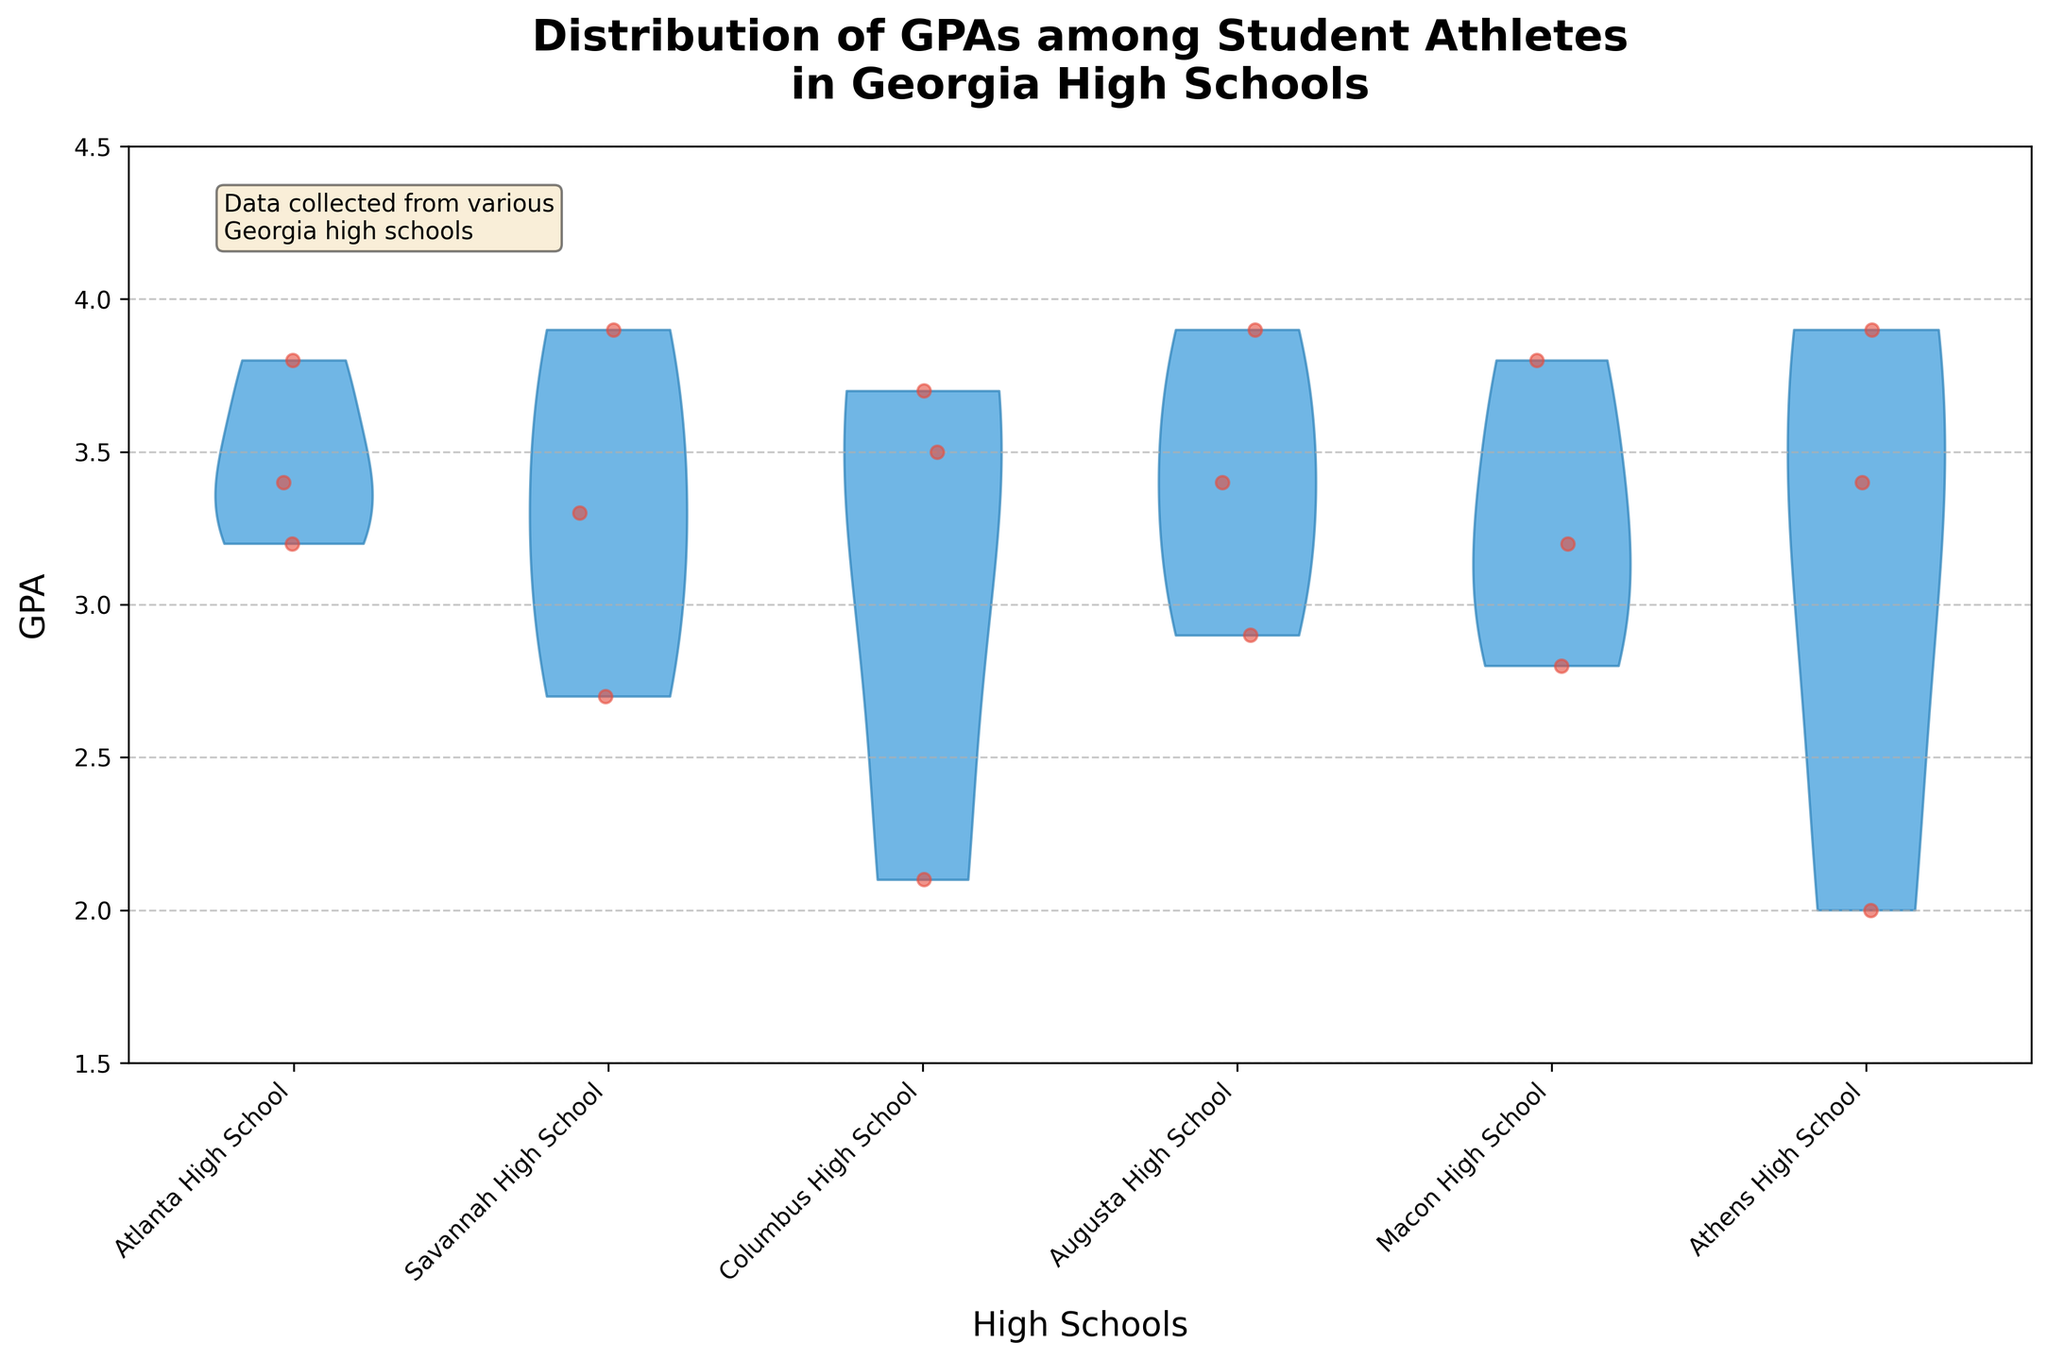Which high school shows the widest distribution of GPAs among student athletes? To determine the widest distribution, observe the range of the violin plots. The widest distribution occurs where the plot spans the greatest vertical distance on the GPA axis.
Answer: Savannah High School Which high school has the highest median GPA among the student athletes? Although the medians are not explicitly shown on the violin plot, the thickest part of the plot generally represents the median. Observe which school has the thickest part positioned highest on the GPA axis.
Answer: Athens High School How many student athletes from Atlanta High School are displayed on the plot? Count the number of red jittered points (dots) associated with the Atlanta High School's violin plot.
Answer: 3 Which high school has the least variance in GPAs among its student athletes? The high school with the least variance will have the narrowest violin plot, indicating that the GPAs are closely clustered around the mean.
Answer: Macon High School Comparing Augusta High School and Macon High School, which has more student athletes with GPAs above 3.5? Count the red jittered points above the 3.5 GPA line for both Augusta High School and Macon High School.
Answer: Augusta High School Is there a school where all student athletes have GPAs below 3.0? Check each violin plot to see if any have no red jittered points (dots) above the 3.0 GPA line.
Answer: Columbus High School What is the average GPA of student athletes from Columbus High School? Sum up the GPAs of student athletes from Columbus High School and divide by the number of students. GPAs = 3.7, 2.1, 3.5; Average = (3.7 + 2.1 + 3.5) / 3 = 3.1
Answer: 3.1 Which high school has the most student athletes with GPAs in the "A" range (3.7 - 4.0)? Count the number of red jittered points in the GPA range of 3.7 to 4.0 for each high school.
Answer: Athens High School How does the overall distribution of GPAs compare between Atlanta High School and Savannah High School? Compare the shape, spread, and number of data points (red jittered points) of the violin plots for both schools. Identify differences in their distributions.
Answer: Savannah High School has a wider distribution with more variation in GPAs What is the overall trend in the GPA distribution of student athletes across all the Georgia high schools shown in the plot? Look at the shapes and spread of the violin plots across all schools. Identify common patterns or generalizations about the GPA distributions.
Answer: Most schools show a concentration of GPAs around the 3.0-3.5 range, with few students having extremely high or low GPAs 